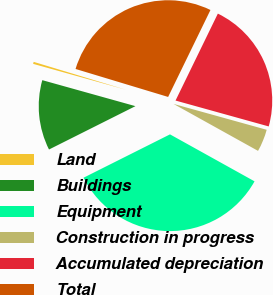Convert chart to OTSL. <chart><loc_0><loc_0><loc_500><loc_500><pie_chart><fcel>Land<fcel>Buildings<fcel>Equipment<fcel>Construction in progress<fcel>Accumulated depreciation<fcel>Total<nl><fcel>0.34%<fcel>11.73%<fcel>34.53%<fcel>3.76%<fcel>22.1%<fcel>27.54%<nl></chart> 